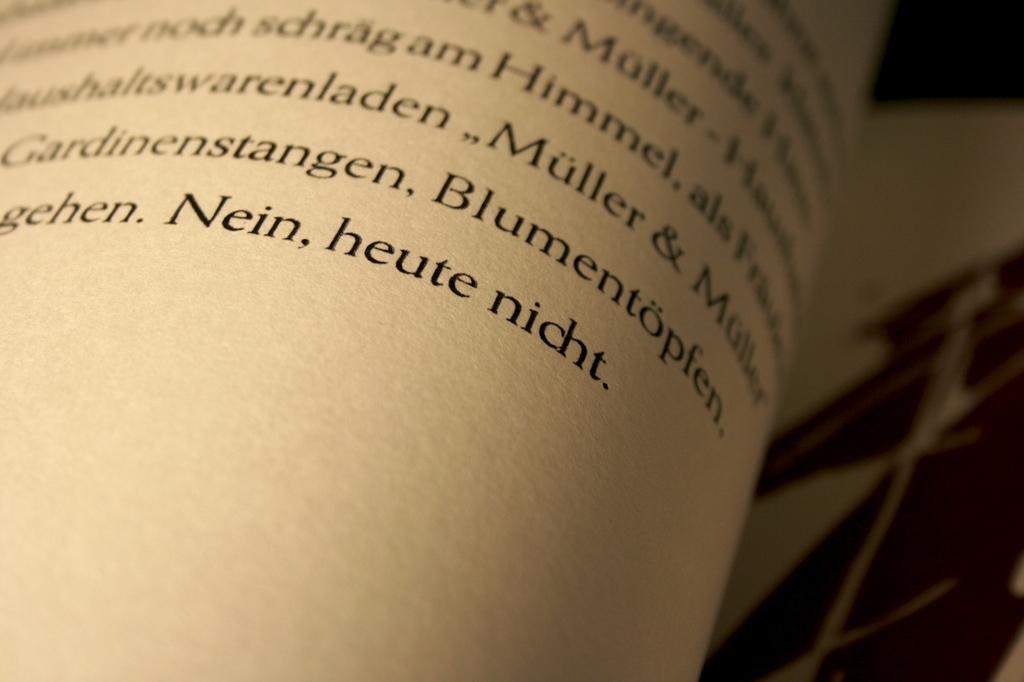How many times the word muller is appear in the picture?
Your response must be concise. 3. 